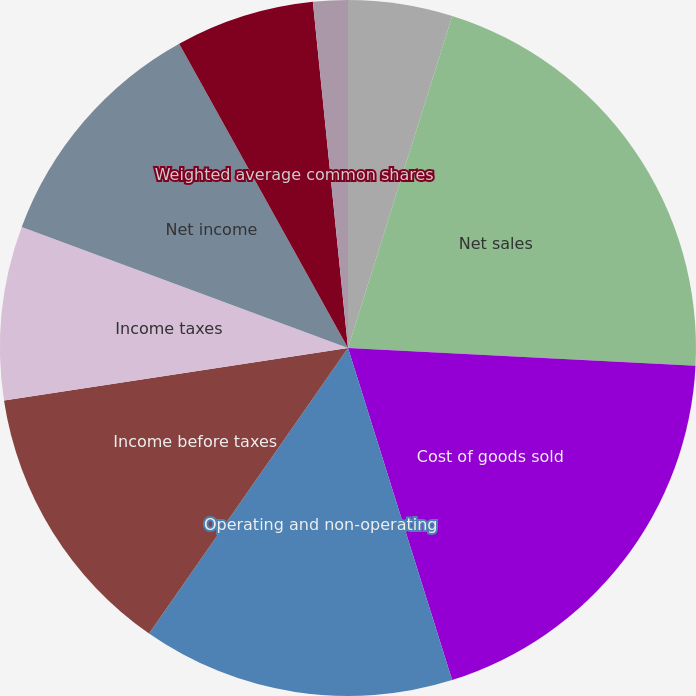Convert chart. <chart><loc_0><loc_0><loc_500><loc_500><pie_chart><fcel>Year Ended December 31<fcel>Net sales<fcel>Cost of goods sold<fcel>Operating and non-operating<fcel>Income before taxes<fcel>Income taxes<fcel>Net income<fcel>Weighted average common shares<fcel>Diluted net income<fcel>Dividends declared<nl><fcel>4.84%<fcel>20.97%<fcel>19.35%<fcel>14.52%<fcel>12.9%<fcel>8.06%<fcel>11.29%<fcel>6.45%<fcel>1.61%<fcel>0.0%<nl></chart> 